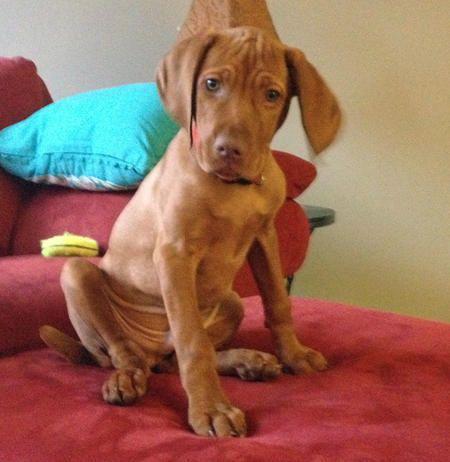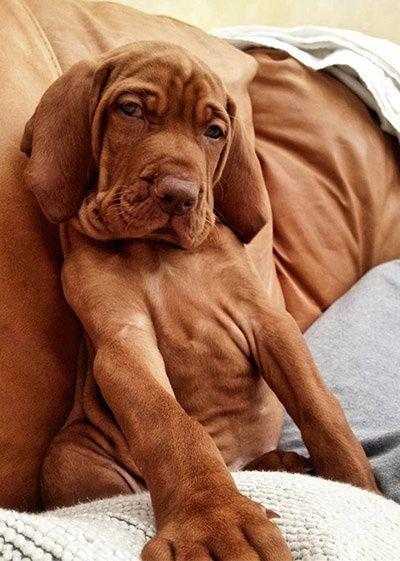The first image is the image on the left, the second image is the image on the right. For the images shown, is this caption "There are exactly two dogs." true? Answer yes or no. Yes. The first image is the image on the left, the second image is the image on the right. For the images shown, is this caption "One dog faces straight ahead, at least one dog is wearing a blue collar, and at least two dogs are wearing collars." true? Answer yes or no. No. 